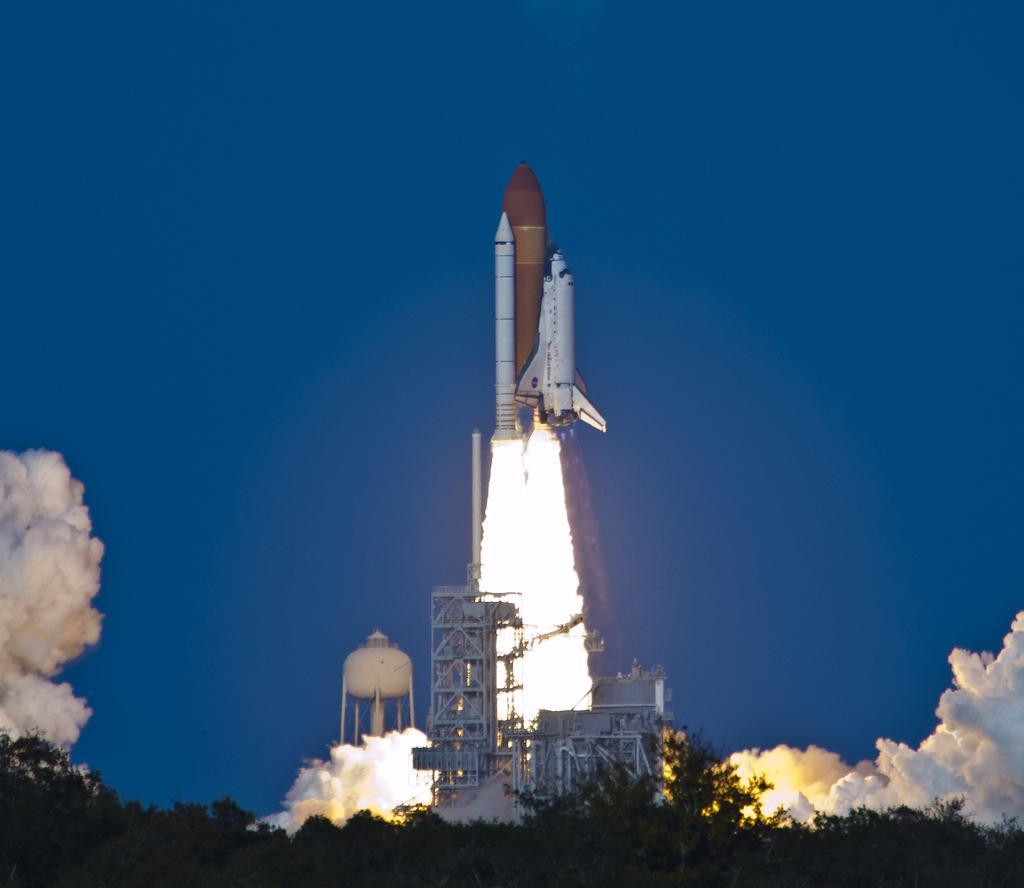How would you summarize this image in a sentence or two? In this image I can see a rocket, trees, smoke, few iron rods and sky is in blue color. 